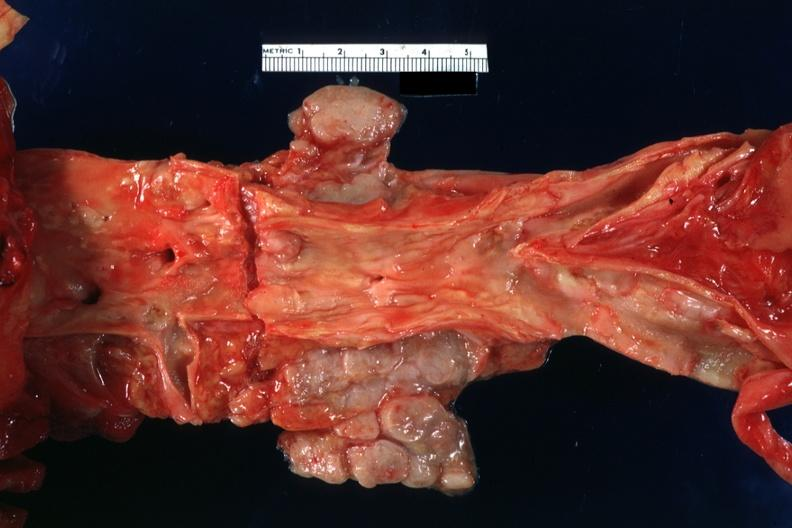what is present?
Answer the question using a single word or phrase. Metastatic carcinoid 